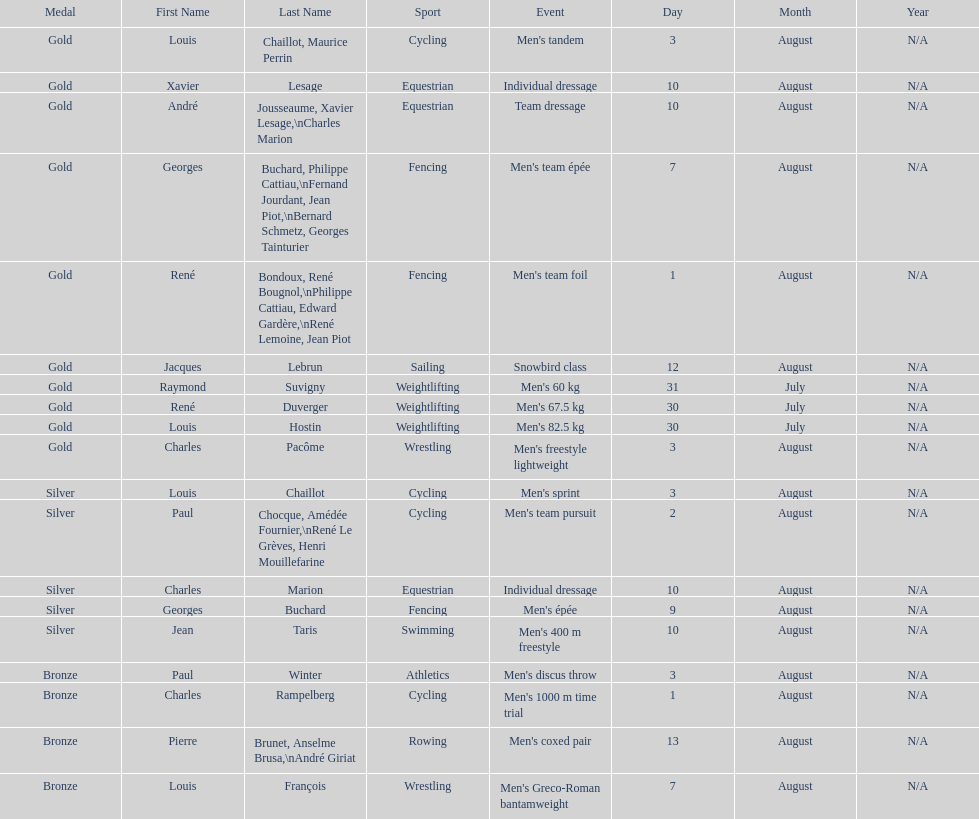What event is listed right before team dressage? Individual dressage. 